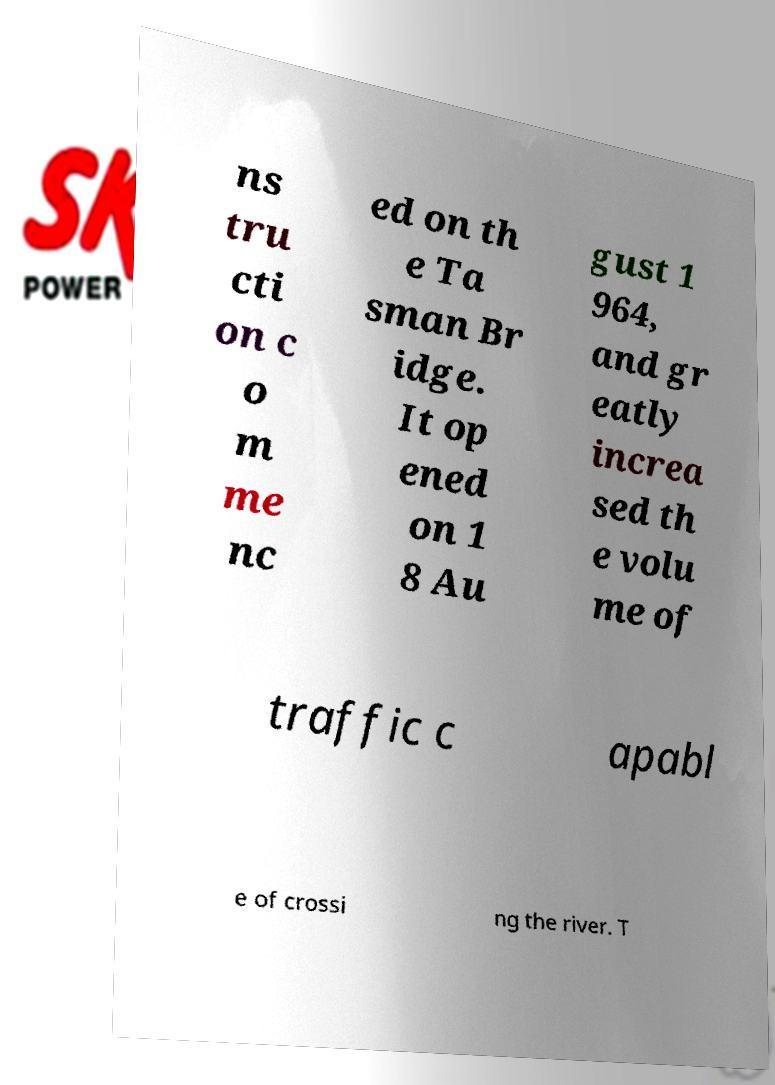Can you read and provide the text displayed in the image?This photo seems to have some interesting text. Can you extract and type it out for me? ns tru cti on c o m me nc ed on th e Ta sman Br idge. It op ened on 1 8 Au gust 1 964, and gr eatly increa sed th e volu me of traffic c apabl e of crossi ng the river. T 